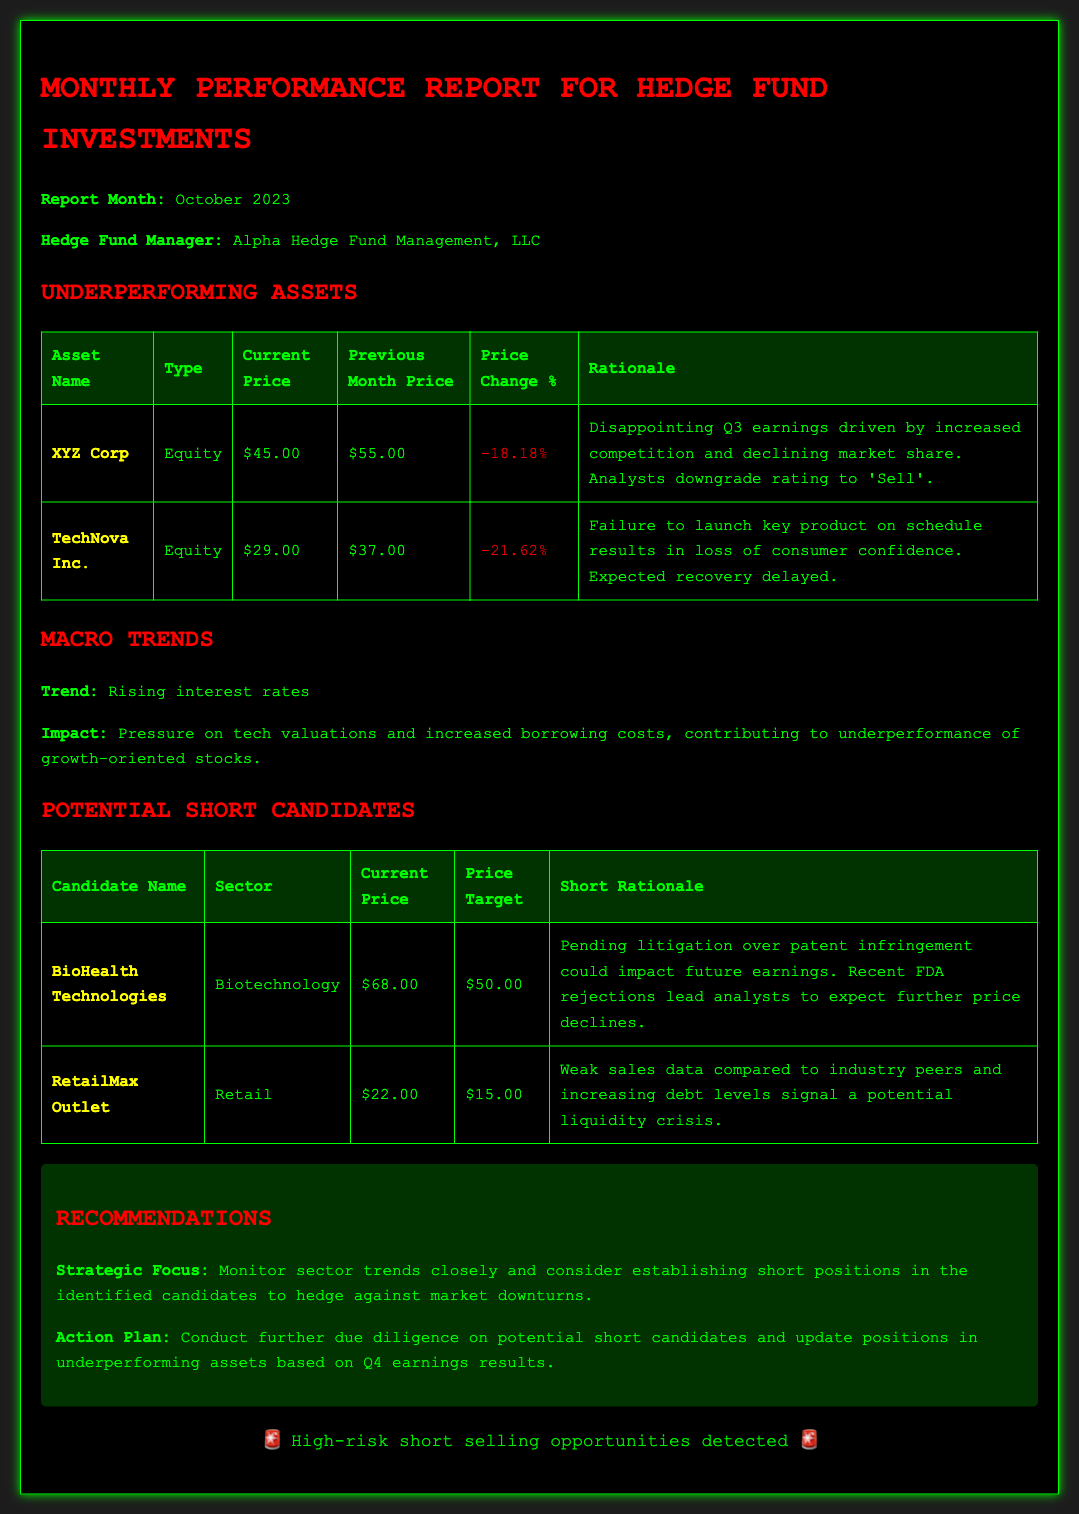What is the report month? The report month is explicitly mentioned in the document's introduction section, which states "Report Month: October 2023".
Answer: October 2023 What is the price change percentage for XYZ Corp? This information is in the Underperforming Assets table, showing the specific price change percentage for XYZ Corp is -18.18%.
Answer: -18.18% Who is the Hedge Fund Manager? The name of the hedge fund manager is provided in the document, specifically "Alpha Hedge Fund Management, LLC".
Answer: Alpha Hedge Fund Management, LLC What is the current price of RetailMax Outlet? RetailMax Outlet's current price is listed in the Potential Short Candidates table.
Answer: $22.00 What is the short rationale for BioHealth Technologies? The document provides a rationale which states that pending litigation and FDA rejections could impact future earnings for BioHealth Technologies.
Answer: Pending litigation over patent infringement could impact future earnings. Recent FDA rejections lead analysts to expect further price declines What sector does TechNova Inc. belong to? This information can be found in the Underperforming Assets table, indicating the asset type for TechNova Inc.
Answer: Equity Which asset experienced the largest price decline? The analysis of the Underperforming Assets table shows the price change percentage for each asset, indicating which had the highest decrease.
Answer: TechNova Inc What is the recommended action for underperforming assets? The Recommendations section suggests a strategic focus and action plan for such assets.
Answer: Conduct further due diligence on potential short candidates and update positions in underperforming assets based on Q4 earnings results 